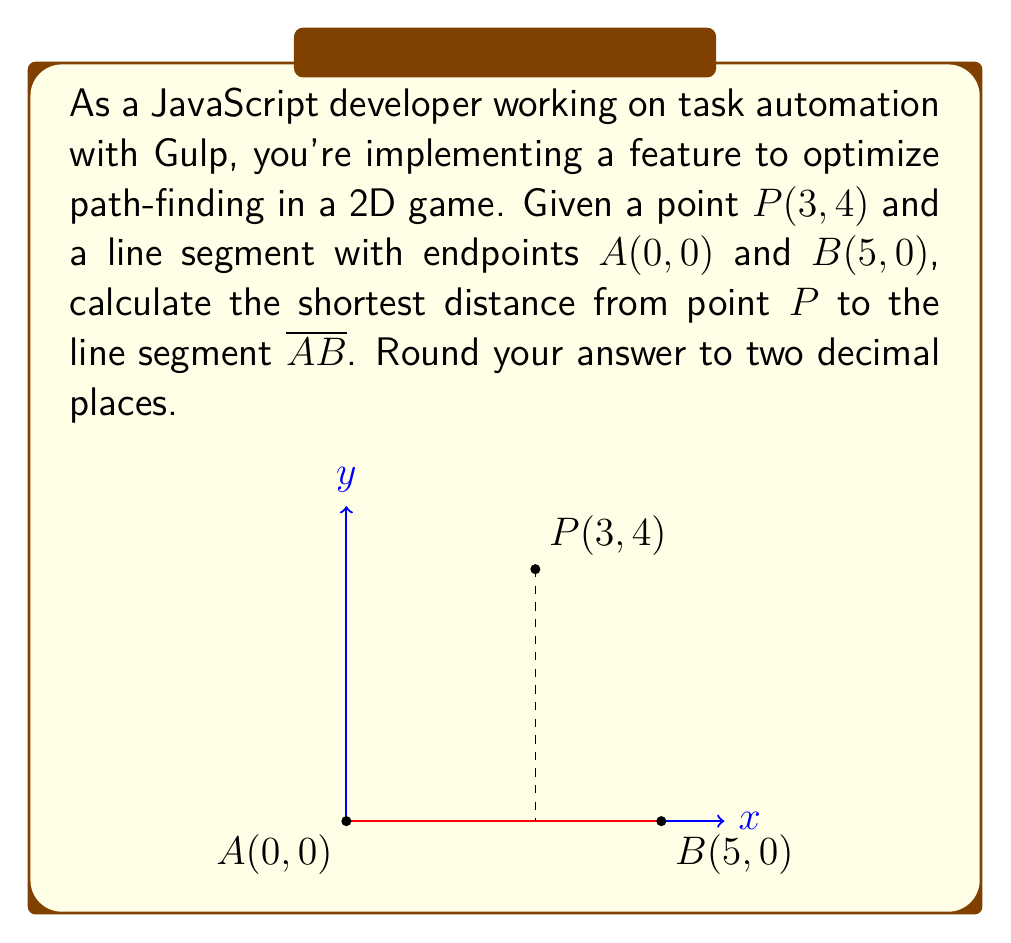What is the answer to this math problem? Let's approach this step-by-step:

1) First, we need to determine if the shortest distance is to a point on the line segment or to one of its endpoints.

2) To do this, we can use the dot product. Let's define vectors:
   $\vec{v} = B - A = (5-0, 0-0) = (5, 0)$
   $\vec{w} = P - A = (3-0, 4-0) = (3, 4)$

3) Calculate the dot product of $\vec{v}$ and $\vec{w}$:
   $\vec{v} \cdot \vec{w} = 5 * 3 + 0 * 4 = 15$

4) Calculate the magnitude of $\vec{v}$ squared:
   $|\vec{v}|^2 = 5^2 + 0^2 = 25$

5) If $0 \leq \frac{\vec{v} \cdot \vec{w}}{|\vec{v}|^2} \leq 1$, the shortest distance is to a point on the line segment.

   $\frac{\vec{v} \cdot \vec{w}}{|\vec{v}|^2} = \frac{15}{25} = 0.6$

   Since $0 \leq 0.6 \leq 1$, the shortest distance is indeed to a point on the line segment.

6) The formula for the shortest distance from a point $(x_0, y_0)$ to a line $ax + by + c = 0$ is:

   $d = \frac{|ax_0 + by_0 + c|}{\sqrt{a^2 + b^2}}$

7) Our line segment is on the x-axis, so its equation is $y = 0$ or $0x + 1y + 0 = 0$

8) Plugging into our distance formula:

   $d = \frac{|0(3) + 1(4) + 0|}{\sqrt{0^2 + 1^2}} = \frac{4}{\sqrt{1}} = 4$

9) Rounding to two decimal places: 4.00
Answer: 4.00 